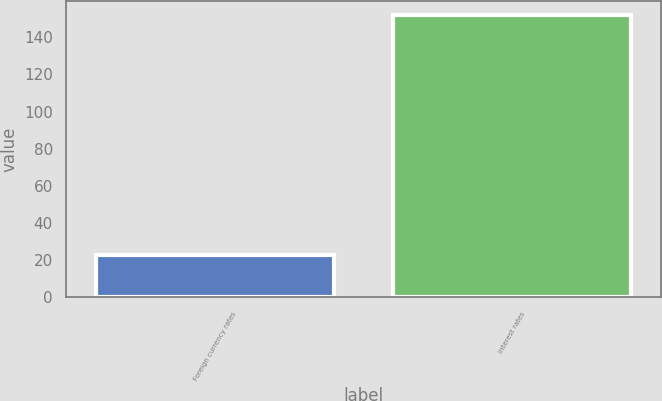Convert chart to OTSL. <chart><loc_0><loc_0><loc_500><loc_500><bar_chart><fcel>Foreign currency rates<fcel>Interest rates<nl><fcel>23<fcel>152<nl></chart> 